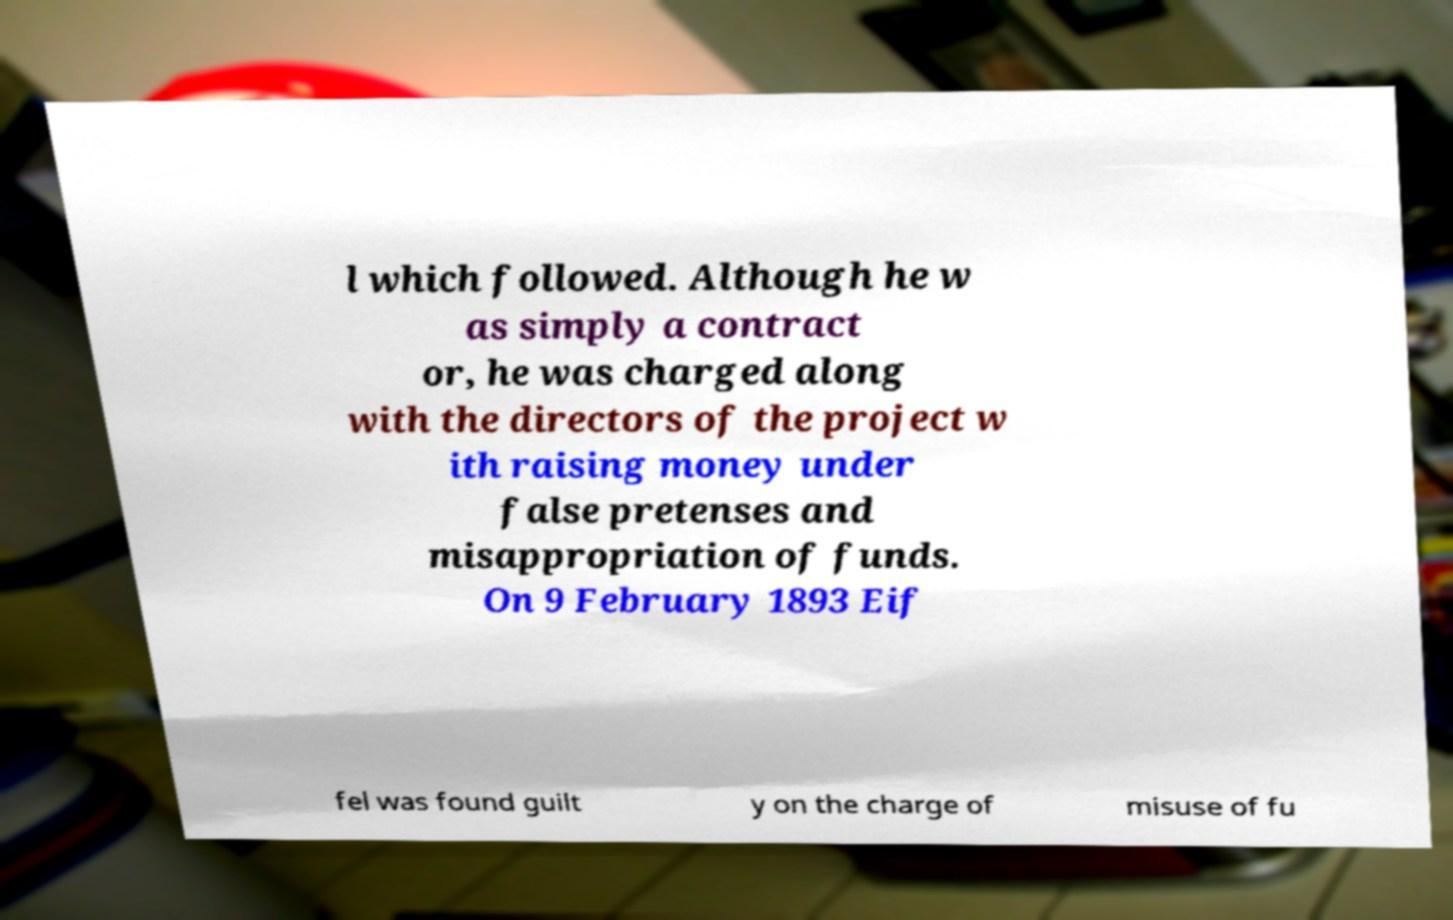Can you read and provide the text displayed in the image?This photo seems to have some interesting text. Can you extract and type it out for me? l which followed. Although he w as simply a contract or, he was charged along with the directors of the project w ith raising money under false pretenses and misappropriation of funds. On 9 February 1893 Eif fel was found guilt y on the charge of misuse of fu 